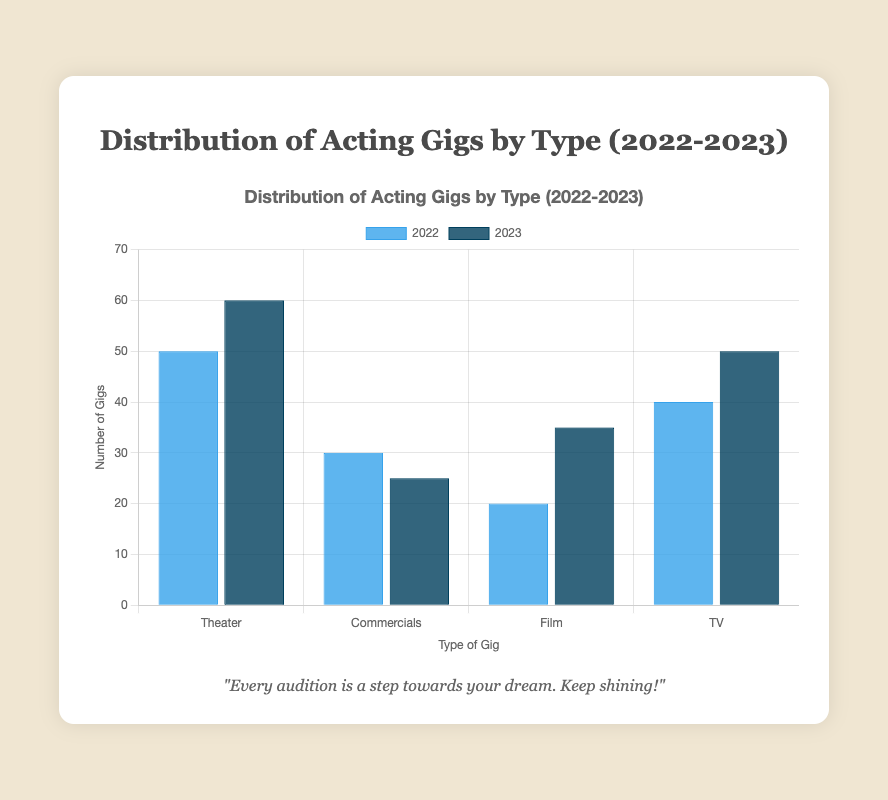Which type of gig saw the most significant increase from 2022 to 2023? To determine the most significant increase, subtract the 2022 value from the 2023 value for each type of gig. Theater: 60 - 50 = 10; Commercials: 25 - 30 = -5; Film: 35 - 20 = 15; TV: 50 - 40 = 10. The Film category has the greatest increase of 15 gigs.
Answer: Film Which type of gig saw the biggest decrease from 2022 to 2023? Determine the differences between 2022 and 2023 for each category: Theater (60 - 50 = 10), Commercials (25 - 30 = -5), Film (35 - 20 = 15), TV (50 - 40 = 10). Commercials have the greatest decrease of -5 gigs.
Answer: Commercials What was the total number of gigs in 2022? Add up all the values for 2022: Theater (50) + Commercials (30) + Film (20) + TV (40) = 140.
Answer: 140 What was the average number of gigs per category in 2023? Add the 2023 values: Theater (60) + Commercials (25) + Film (35) + TV (50) = 170. Then, divide by the number of categories (4): 170 / 4 = 42.5.
Answer: 42.5 Which category had a higher number of gigs in 2023 compared to 2022? Compare each category: Theater (60 > 50), Commercials (25 < 30), Film (35 > 20), TV (50 > 40). The categories with more gigs in 2023 than in 2022 are Theater, Film, and TV.
Answer: Theater, Film, TV Between Theater and TV, which category had more gigs in 2023? Compare the values for 2023: Theater (60) and TV (50). Theater had more gigs in 2023.
Answer: Theater By how much did the total number of gigs change from 2022 to 2023? Calculate the total for each year and find the difference: 2022 (140), 2023 (170). The change is 170 - 140 = 30.
Answer: 30 What is the ratio of Theater gigs in 2023 to Commercials gigs in 2022? The number of Theater gigs in 2023 is 60, and the number of Commercials gigs in 2022 is 30. The ratio is 60 / 30 = 2.
Answer: 2 What percentage increase did the Film category experience from 2022 to 2023? Calculate the increase: 35 (2023) - 20 (2022) = 15. Then, find the percentage: (15 / 20) * 100 = 75%.
Answer: 75% How many more gigs were there in the Film category in 2023 than in Commercials in 2023? Subtract the number of Commercials gigs in 2023 (25) from the number of Film gigs in 2023 (35): 35 - 25 = 10.
Answer: 10 